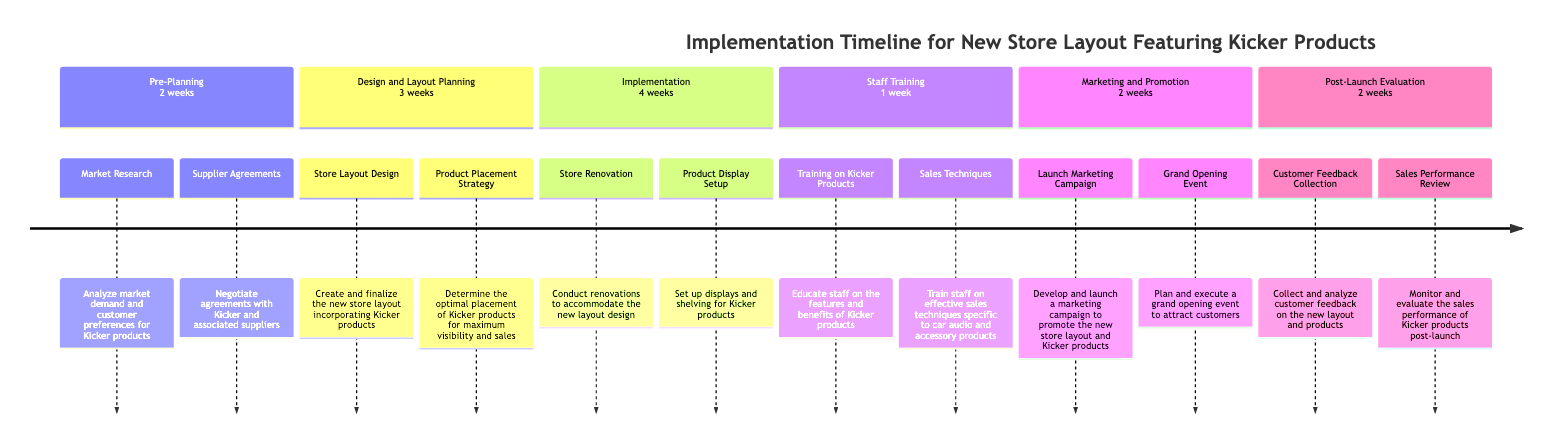What is the duration of the Pre-Planning phase? The Pre-Planning phase is specified in the timeline, indicating that it lasts for 2 weeks.
Answer: 2 weeks How many tasks are there in the Implementation phase? The Implementation phase includes two tasks: "Store Renovation" and "Product Display Setup." Therefore, the total number of tasks in this phase is 2.
Answer: 2 What is the first task in the Design and Layout Planning phase? The first task listed in the Design and Layout Planning phase is "Store Layout Design," indicating that it is the initial task to be undertaken in this phase.
Answer: Store Layout Design What is the last phase in the implementation timeline? The last phase in the timeline is "Post-Launch Evaluation." This is the final grouping of tasks that occurs after the store layout has been implemented.
Answer: Post-Launch Evaluation How long does Staff Training take compared to the Marketing and Promotion phase? Staff Training lasts for 1 week, while Marketing and Promotion lasts for 2 weeks. Thus, Marketing and Promotion takes longer by 1 week.
Answer: 1 week What is the duration for collecting customer feedback? The duration for collecting customer feedback, as indicated in the Post-Launch Evaluation phase, is 2 weeks.
Answer: 2 weeks How does the duration of the Implementation phase compare to the Design and Layout Planning phase? The Implementation phase lasts for 4 weeks, while the Design and Layout Planning phase lasts for 3 weeks. Therefore, Implementation is 1 week longer than Design and Layout Planning.
Answer: 1 week longer Which task focuses on training staff on Kicker products? The task focusing on training staff on Kicker products is “Training on Kicker Products,” which is explicitly mentioned in the Staff Training phase.
Answer: Training on Kicker Products 